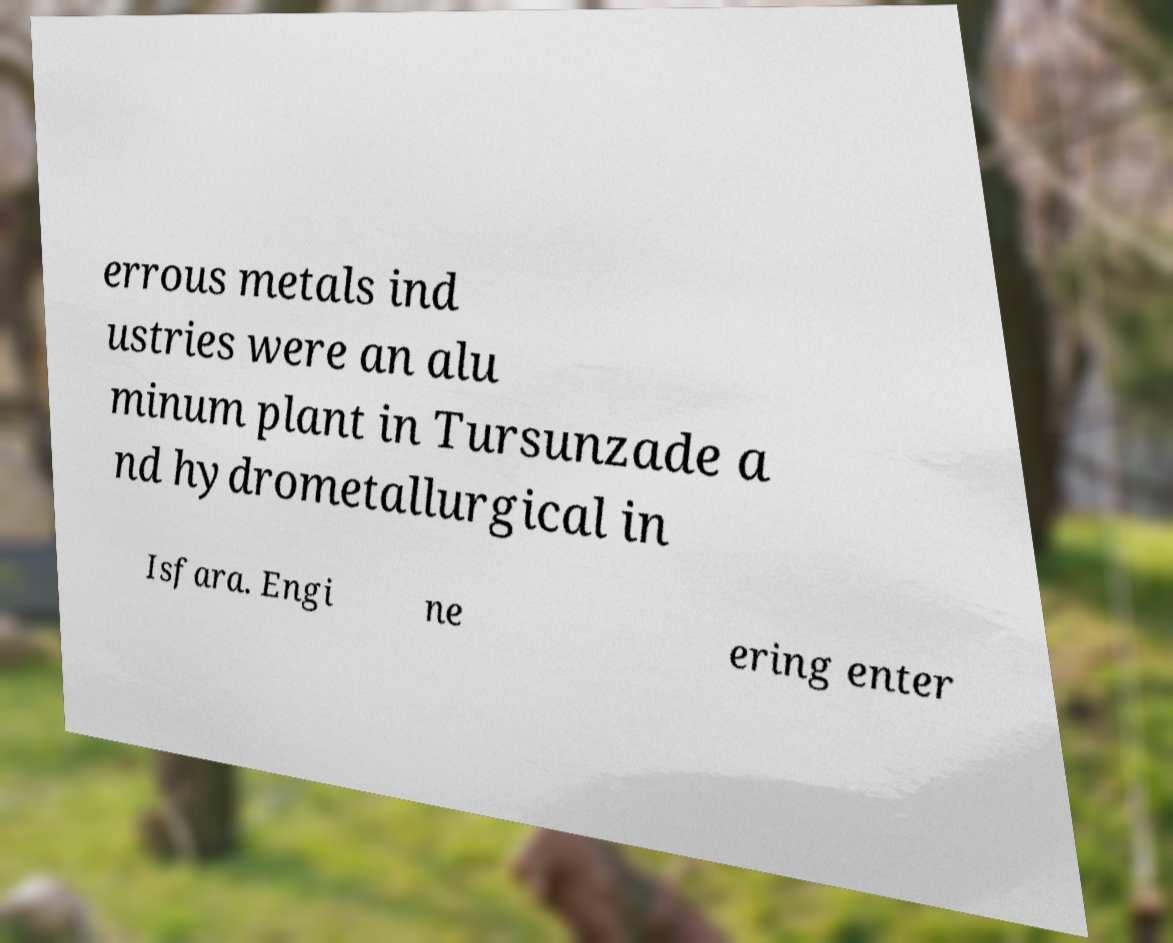Can you read and provide the text displayed in the image?This photo seems to have some interesting text. Can you extract and type it out for me? errous metals ind ustries were an alu minum plant in Tursunzade a nd hydrometallurgical in Isfara. Engi ne ering enter 